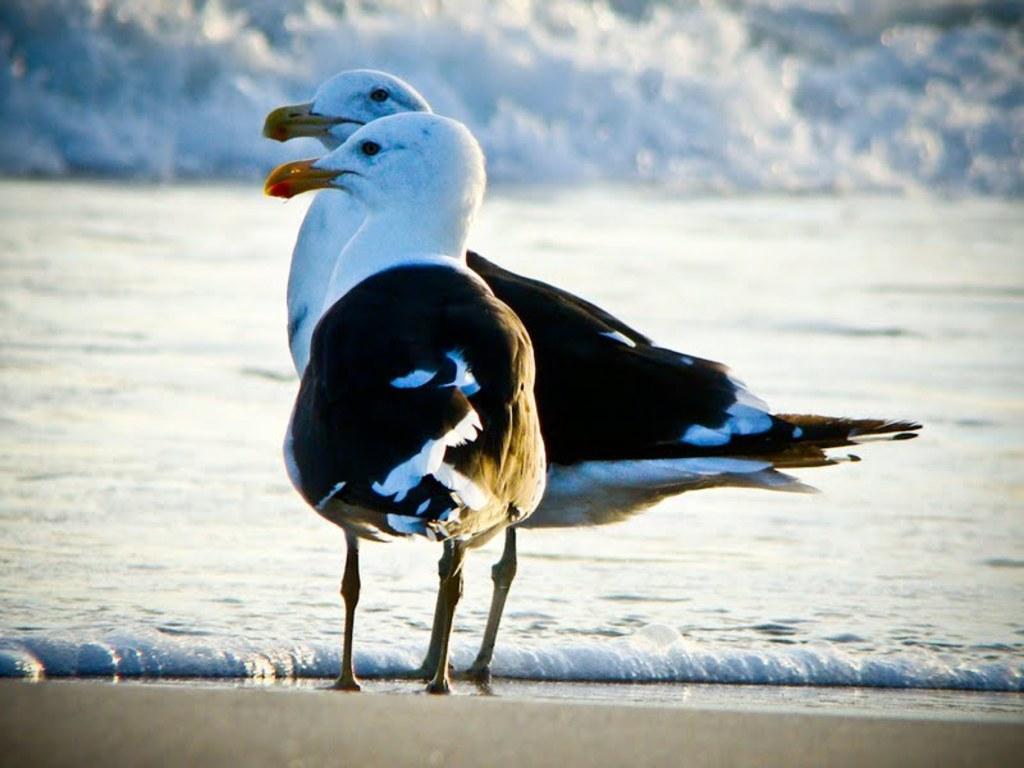Could you give a brief overview of what you see in this image? There are Great black-backed gull standing and there is water in front of it. 